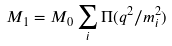<formula> <loc_0><loc_0><loc_500><loc_500>M _ { 1 } = M _ { 0 } \sum _ { i } \Pi ( q ^ { 2 } / m _ { i } ^ { 2 } )</formula> 